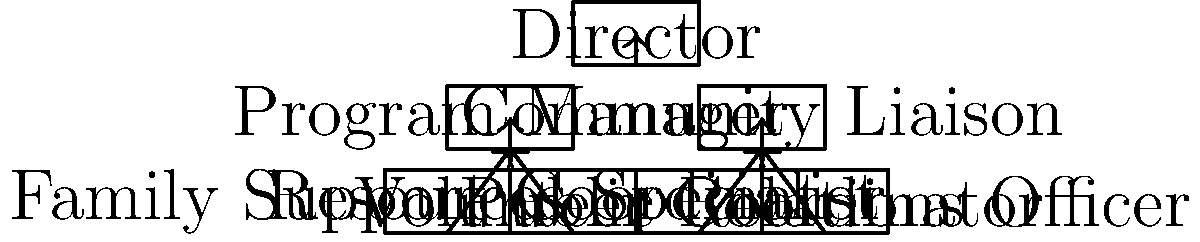In this organizational chart of a military family support network, which position directly oversees both the Family Support Coordinator and the Resources Specialist? To answer this question, let's analyze the organizational chart step-by-step:

1. At the top of the chart, we see the Director position.
2. Below the Director, there are two main branches: Program Manager and Community Liaison.
3. Under the Program Manager, we find two positions: Family Support Coordinator and Resources Specialist.
4. Under the Community Liaison, we see the Volunteer Coordinator and Public Relations Officer.

The key to answering this question is to identify which position is directly above both the Family Support Coordinator and the Resources Specialist in the hierarchy. We can see that both of these positions have arrows pointing up to the Program Manager.

Therefore, the Program Manager is the position that directly oversees both the Family Support Coordinator and the Resources Specialist in this military family support network organizational chart.
Answer: Program Manager 